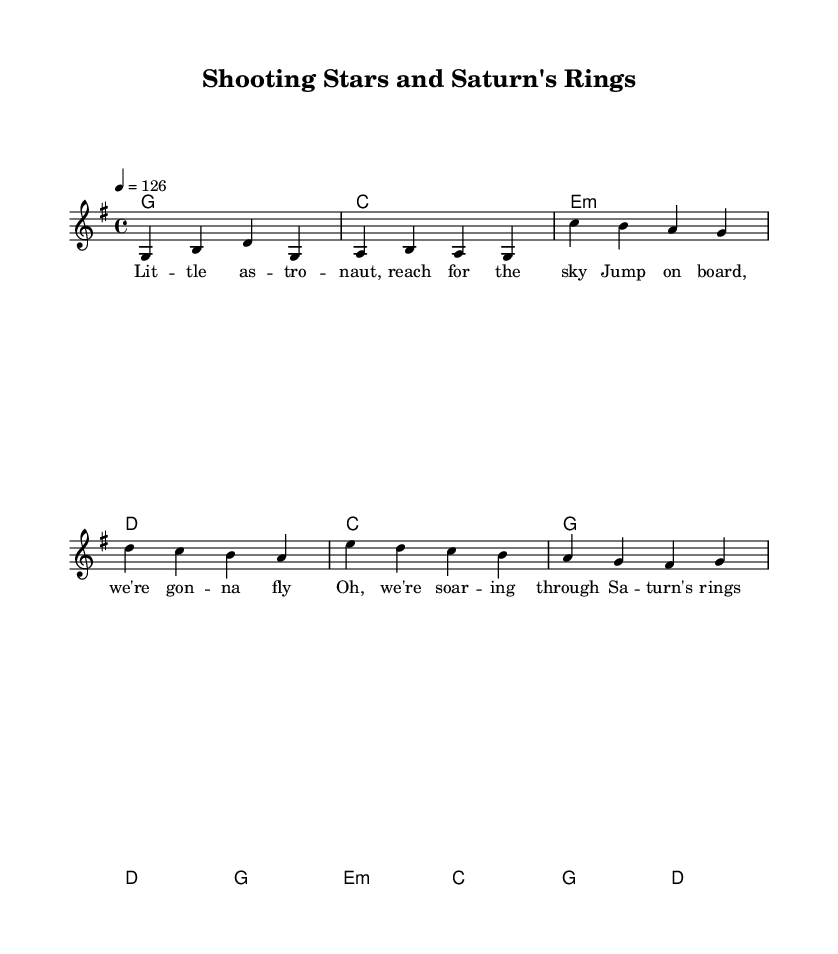What is the key signature of this music? The key signature is G major, which has one sharp (F#). You can determine this by looking at the key signature indicator at the beginning of the staff.
Answer: G major What is the time signature of this music? The time signature is 4/4, which means there are four beats in each measure and the quarter note gets one beat. This is displayed at the beginning of the score, just after the key signature.
Answer: 4/4 What is the tempo marking for this music? The tempo marking is 126 beats per minute, indicated at the beginning of the score. This tells how fast the music should be played.
Answer: 126 How many measures are there in the melody? The melody includes a total of eight measures as we can visually count them in the scored melody sections of both the verse and chorus. Each distinct line or bar separates one measure from another.
Answer: 8 What is the first lyric of the verse? The first lyric of the verse is "Little astronaut," which can be found aligned with the first notes of the melody in the verse.
Answer: Little astronaut What is the chord played in the first measure? The chord in the first measure is G, shown by the chord symbol written above the notes. It indicates which harmony accompanies the melody during that measure.
Answer: G What is the main theme of the song reflected in the lyrics? The main theme of the song is space exploration and discovery, as evidenced by the lyrics discussing an astronaut and learning about cosmic things. This is a central idea expressed throughout the verses and chorus.
Answer: Space exploration 